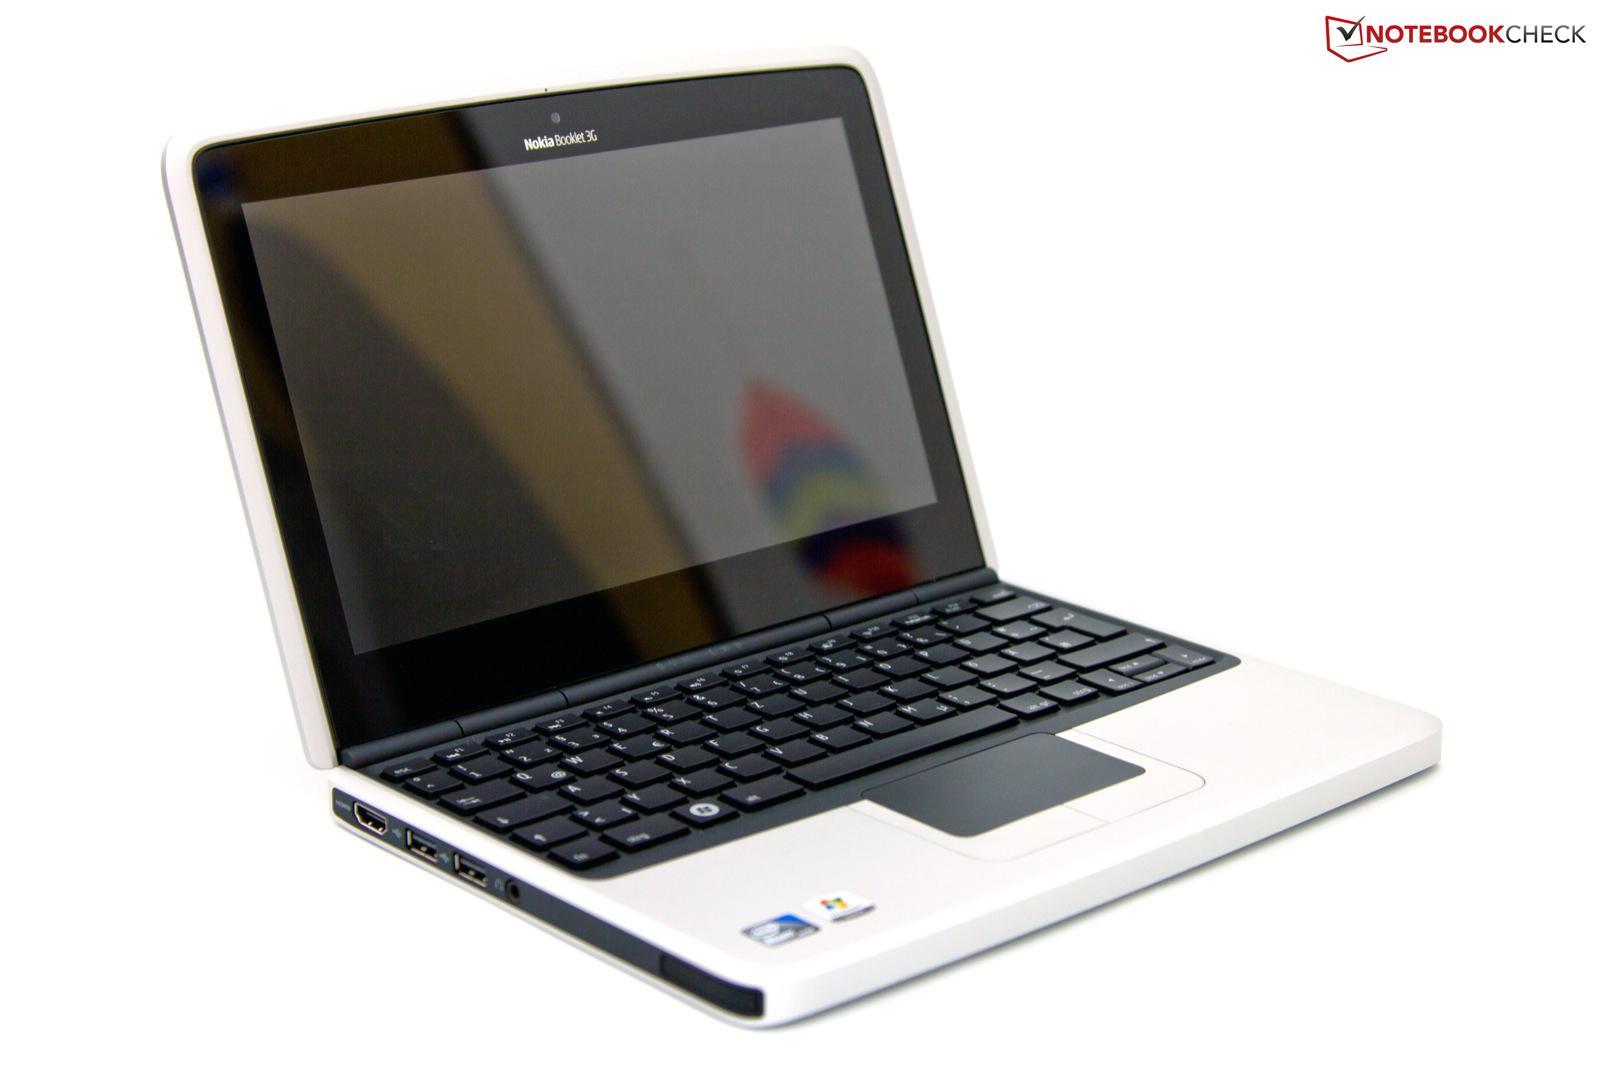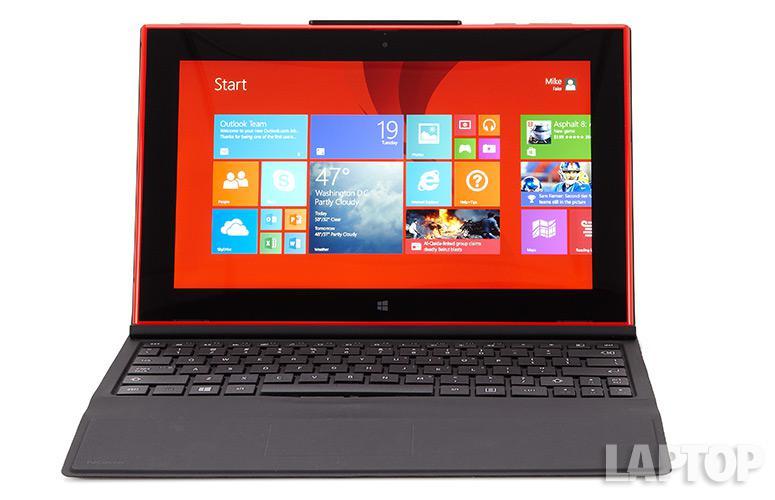The first image is the image on the left, the second image is the image on the right. For the images shown, is this caption "The laptops are facing the same direction in the image on the right." true? Answer yes or no. No. 